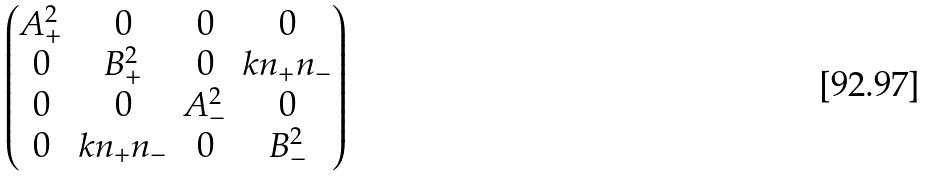Convert formula to latex. <formula><loc_0><loc_0><loc_500><loc_500>\begin{pmatrix} A _ { + } ^ { 2 } & 0 & 0 & 0 \\ 0 & B _ { + } ^ { 2 } & 0 & k n _ { + } n _ { - } \\ 0 & 0 & A _ { - } ^ { 2 } & 0 \\ 0 & k n _ { + } n _ { - } & 0 & B _ { - } ^ { 2 } \end{pmatrix}</formula> 